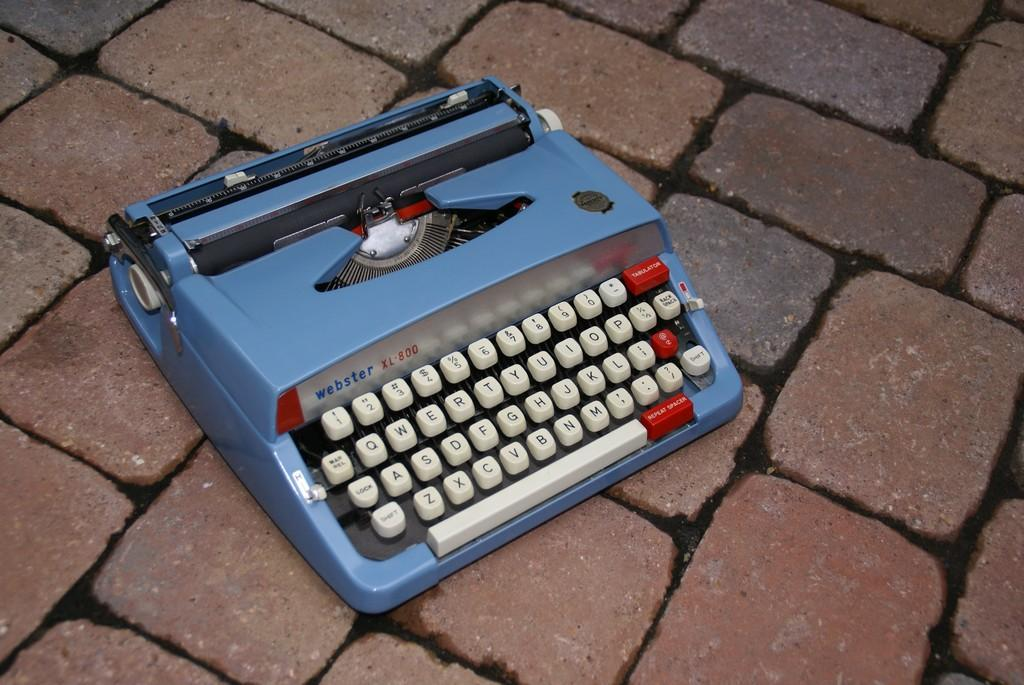<image>
Relay a brief, clear account of the picture shown. A blue, Webster brand typewriter is on a paved surface. 